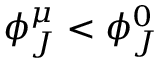<formula> <loc_0><loc_0><loc_500><loc_500>\phi _ { J } ^ { \mu } < \phi _ { J } ^ { 0 }</formula> 